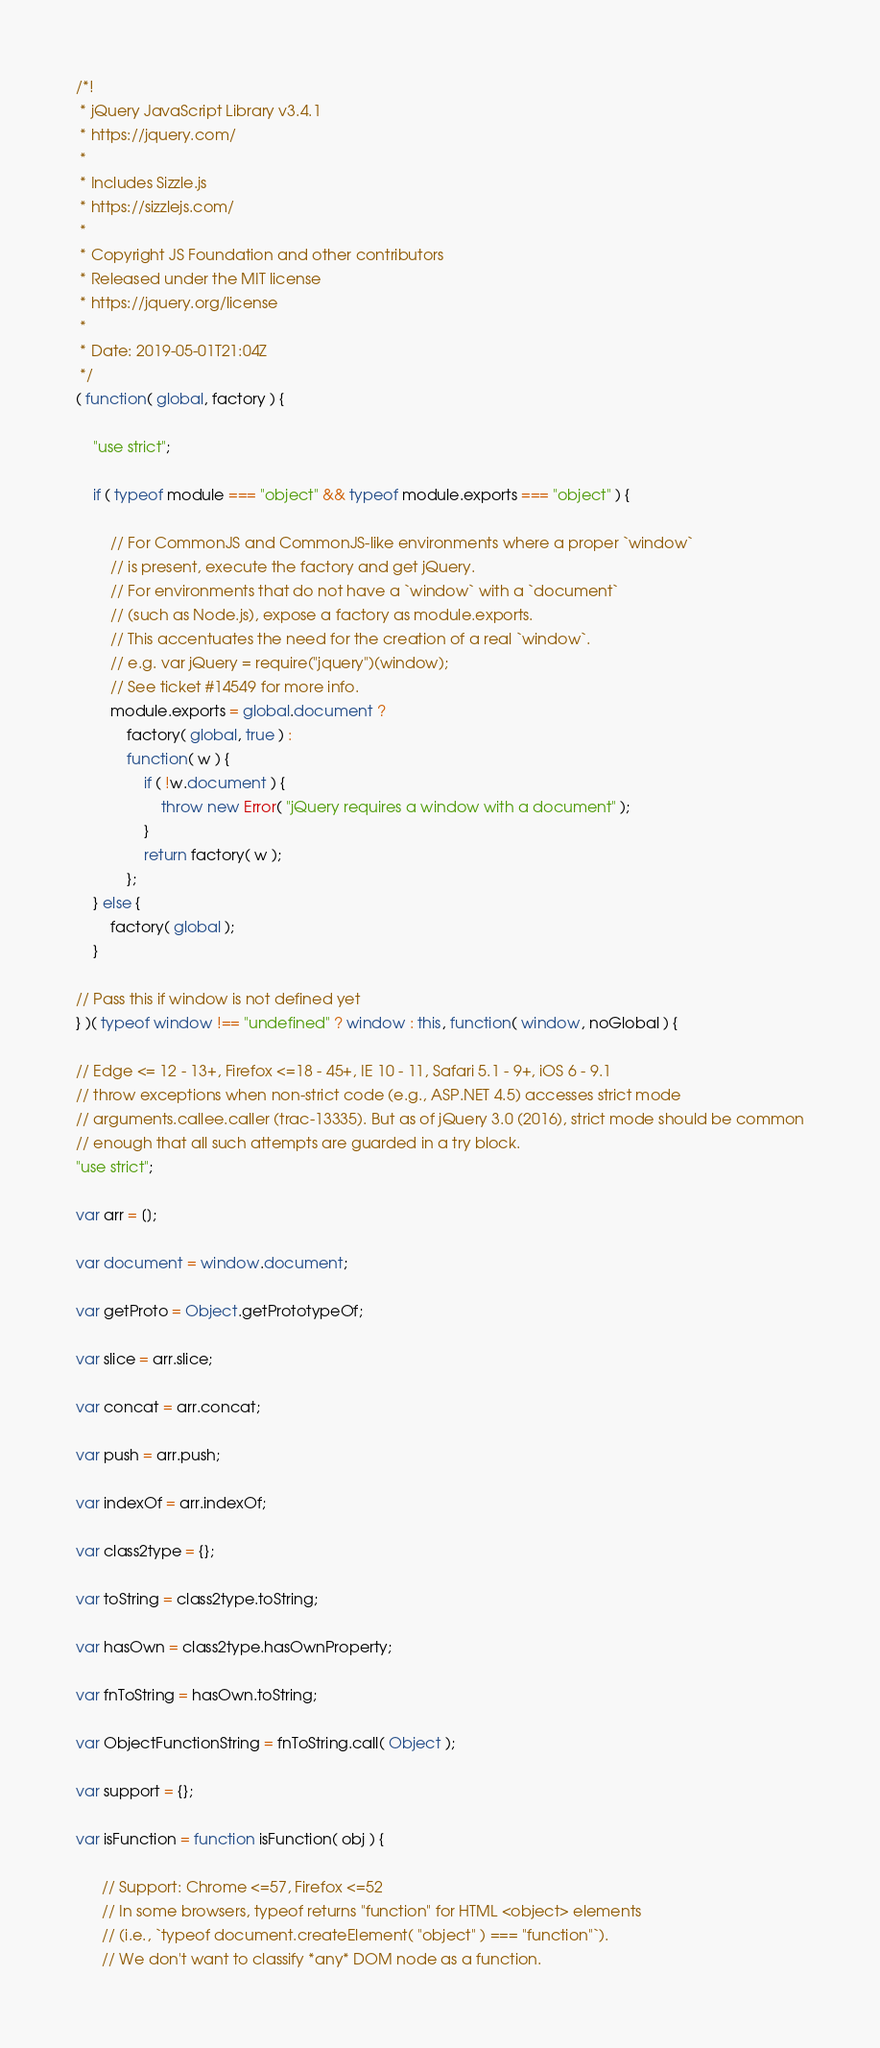Convert code to text. <code><loc_0><loc_0><loc_500><loc_500><_JavaScript_>/*!
 * jQuery JavaScript Library v3.4.1
 * https://jquery.com/
 *
 * Includes Sizzle.js
 * https://sizzlejs.com/
 *
 * Copyright JS Foundation and other contributors
 * Released under the MIT license
 * https://jquery.org/license
 *
 * Date: 2019-05-01T21:04Z
 */
( function( global, factory ) {

	"use strict";

	if ( typeof module === "object" && typeof module.exports === "object" ) {

		// For CommonJS and CommonJS-like environments where a proper `window`
		// is present, execute the factory and get jQuery.
		// For environments that do not have a `window` with a `document`
		// (such as Node.js), expose a factory as module.exports.
		// This accentuates the need for the creation of a real `window`.
		// e.g. var jQuery = require("jquery")(window);
		// See ticket #14549 for more info.
		module.exports = global.document ?
			factory( global, true ) :
			function( w ) {
				if ( !w.document ) {
					throw new Error( "jQuery requires a window with a document" );
				}
				return factory( w );
			};
	} else {
		factory( global );
	}

// Pass this if window is not defined yet
} )( typeof window !== "undefined" ? window : this, function( window, noGlobal ) {

// Edge <= 12 - 13+, Firefox <=18 - 45+, IE 10 - 11, Safari 5.1 - 9+, iOS 6 - 9.1
// throw exceptions when non-strict code (e.g., ASP.NET 4.5) accesses strict mode
// arguments.callee.caller (trac-13335). But as of jQuery 3.0 (2016), strict mode should be common
// enough that all such attempts are guarded in a try block.
"use strict";

var arr = [];

var document = window.document;

var getProto = Object.getPrototypeOf;

var slice = arr.slice;

var concat = arr.concat;

var push = arr.push;

var indexOf = arr.indexOf;

var class2type = {};

var toString = class2type.toString;

var hasOwn = class2type.hasOwnProperty;

var fnToString = hasOwn.toString;

var ObjectFunctionString = fnToString.call( Object );

var support = {};

var isFunction = function isFunction( obj ) {

      // Support: Chrome <=57, Firefox <=52
      // In some browsers, typeof returns "function" for HTML <object> elements
      // (i.e., `typeof document.createElement( "object" ) === "function"`).
      // We don't want to classify *any* DOM node as a function.</code> 